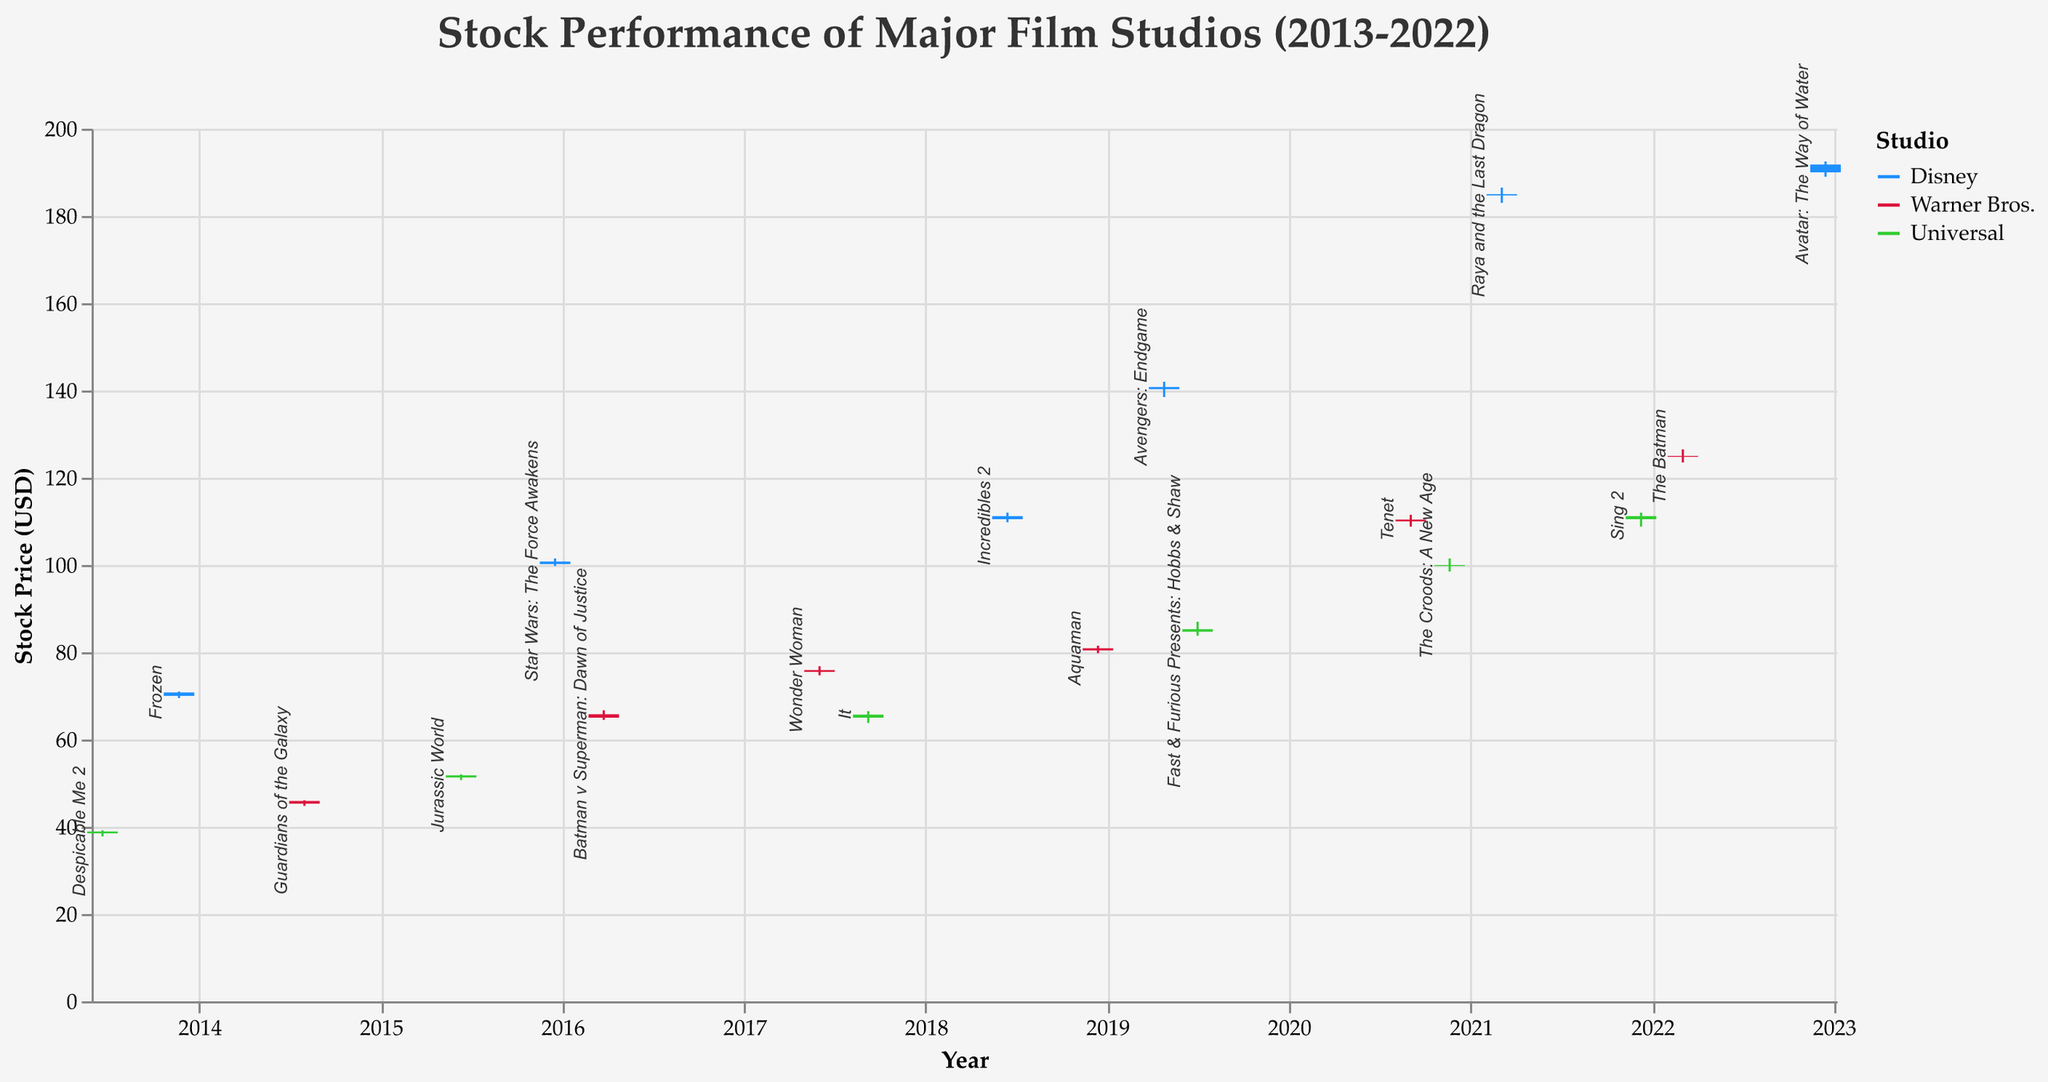What is the overall trend in Disney's stock price from 2013 to 2022? To determine the trend, we look at Disney's stock prices at the beginning and end of the period. In 2013, the price was around $70.80, and in 2022, it was around $191.80. This indicates an increase over the period, showing an upward trend.
Answer: Upward trend Which film release corresponds to the highest stock price increase for Warner Bros.? We compare the highs and lows (difference) for Warner Bros.'s stock across all dates. "The Batman" in 2022 had the highest, with the price moving from $123.50 to $126.50.
Answer: The Batman How did Universal's stock price respond to the release of "Jurassic World"? For "Jurassic World" (2015-06-12), the stock opened at $51.30 and closed at $51.80. This shows a slight increase on the release date.
Answer: Slight increase Which studio had the largest trading volume on a single release date? We compare the volumes for all studios. Disney's release of "Star Wars: The Force Awakens" on 2015-12-18 had the highest volume at 6,500,000.
Answer: Disney What was the closing stock price for Disney on the release of "Frozen"? Referring to the date (2013-11-22) for the release of "Frozen," the closing price for Disney was $70.80.
Answer: 70.80 How do the stock prices of Disney and Universal compare on the release of "Sing 2" by Universal? On 2021-12-10, Universal’s closing price was $111.20. To compare, Disney’s nearby data point (2021-03-05) shows a closing price of $184.70. Disney's stock was significantly higher than Universal’s.
Answer: Disney's stock was higher Identify the release date of a Warner Bros. film where the opening and closing prices were the same. We scan Warner Bros. data to find where open equals close. On "Guardians of the Galaxy" release (2014-08-01), both were equal at $45.90.
Answer: 2014-08-01 Which film release had the lowest closing stock price for Universal? By scanning Universal’s data, we find "Despicable Me 2" (2013-06-21) had the lowest close at $38.90.
Answer: Despicable Me 2 What was the percentage increase in Disney’s stock price from the release of "Incredibles 2" to "Avengers: Endgame"? For "Incredibles 2" (2018-06-15), the closing was $111.20. For "Avengers: Endgame" (2019-04-26), it was $140.80. The percentage increase can be calculated as ((140.80 - 111.20) / 111.20) * 100%.
Answer: 26.62% Did any Universal films release during high volatility periods? High volatility is indicated by a large range between the high and low prices. "It" (2017-09-08) has a notable difference, with a high of $66.50 and a low of $63.80, indicating higher volatility.
Answer: It 